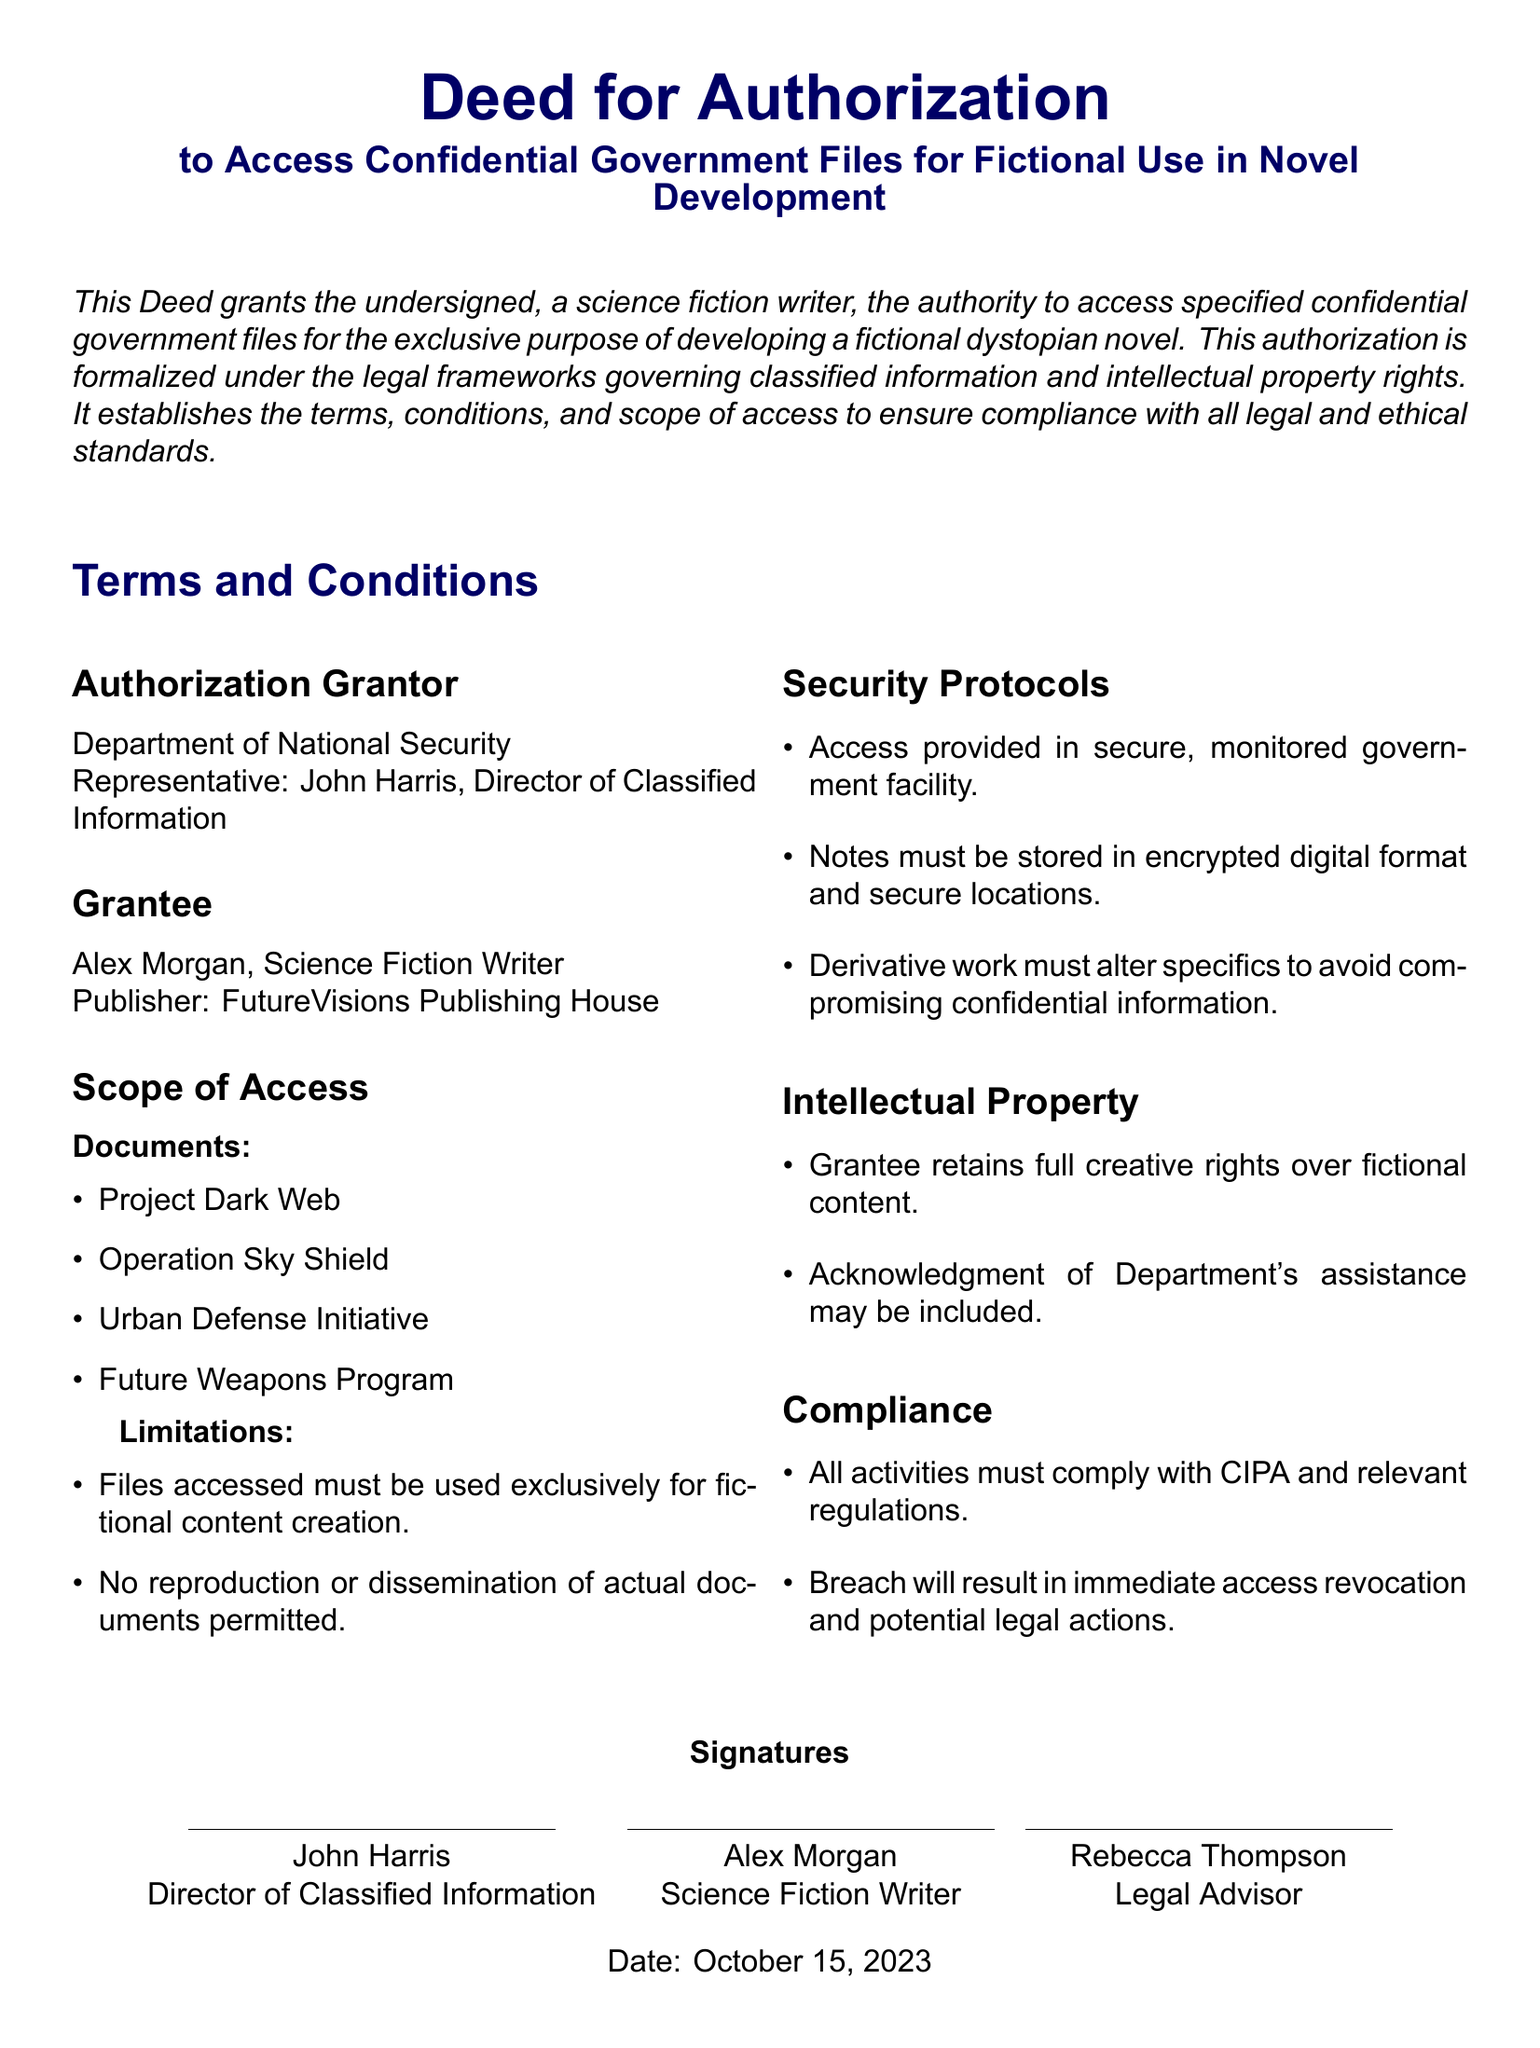What is the name of the authorization grantor? The authorization grantor is identified in the document as the Department of National Security.
Answer: Department of National Security Who is the grantee of the authorization? The document specifies the grantee as Alex Morgan, a science fiction writer.
Answer: Alex Morgan What is the date of the document? The date mentioned in the document is when the deed was signed, which is October 15, 2023.
Answer: October 15, 2023 How many documents are listed under the scope of access? The number of documents indicated in the scope of access provides clarity on what can be accessed, which is four.
Answer: four What is one of the security protocols mentioned? One of the security protocols outlined in the document focuses on the storage of notes in an encrypted format.
Answer: Notes must be stored in encrypted digital format What is the full title of the document? The title given at the beginning of the document indicates its purpose, specifically relating to access for a novel development.
Answer: Deed for Authorization to Access Confidential Government Files for Fictional Use in Novel Development What happens in case of a breach of the agreement? The consequences of breaching the agreement are specified in the document and include revocation of access and potential legal actions.
Answer: Immediate access revocation and potential legal actions Which organization must be acknowledged in the fictional content? The deed mentions that acknowledgment should be given if the Department assists in the content creation.
Answer: Department of National Security What is the main purpose of granting access? The primary intent of the access is clarified in the document as being for developing fictional content for a novel.
Answer: Developing a fictional dystopian novel 